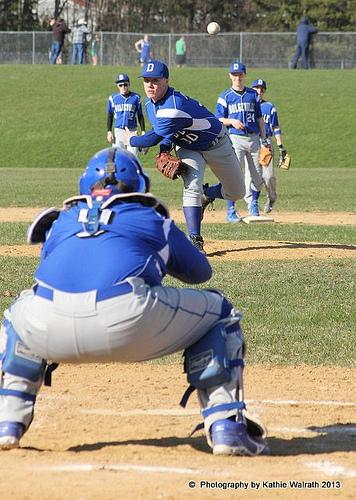Point out the main figure in the image and the action occurring. A blue and white uniformed baseball player is the center of attention, as a white baseball is thrown. Explain the key object in the image and the ongoing event. A baseball player in blue and white uniform is the central focus, with a white baseball being tossed. Describe the primary subject in the image and the related action. The main subject is a baseball player wearing a blue and white uniform, with a white baseball being thrown. Identify the main subject of the photo and describe the action happening. The central subject is a baseball player in a blue and white uniform, as a white baseball is thrown. Mention the key element in the picture and what action is happening. A baseball player is positioned in the background as another player throws a white baseball in the air. Indicate the primary focus of the image and describe the ongoing activity. A baseball player in a blue and white uniform is the main focus, with a white baseball being thrown. State the central figure in the scene and describe the ongoing activity. A baseball player, wearing a blue and white uniform, is in action as a white baseball is thrown in the air. Highlight the central aspect of the image and the action in progress. Focus is on a baseball player in blue and white uniform, as a white baseball is thrown in the air. What is the focal point of the image and the action taking place? The focus is a baseball player in a blue and white uniform, with a white baseball being thrown. Tell me the main content of the image and the ongoing event. Baseball players dressed in blue and white uniforms are competing, one is throwing a white baseball. 